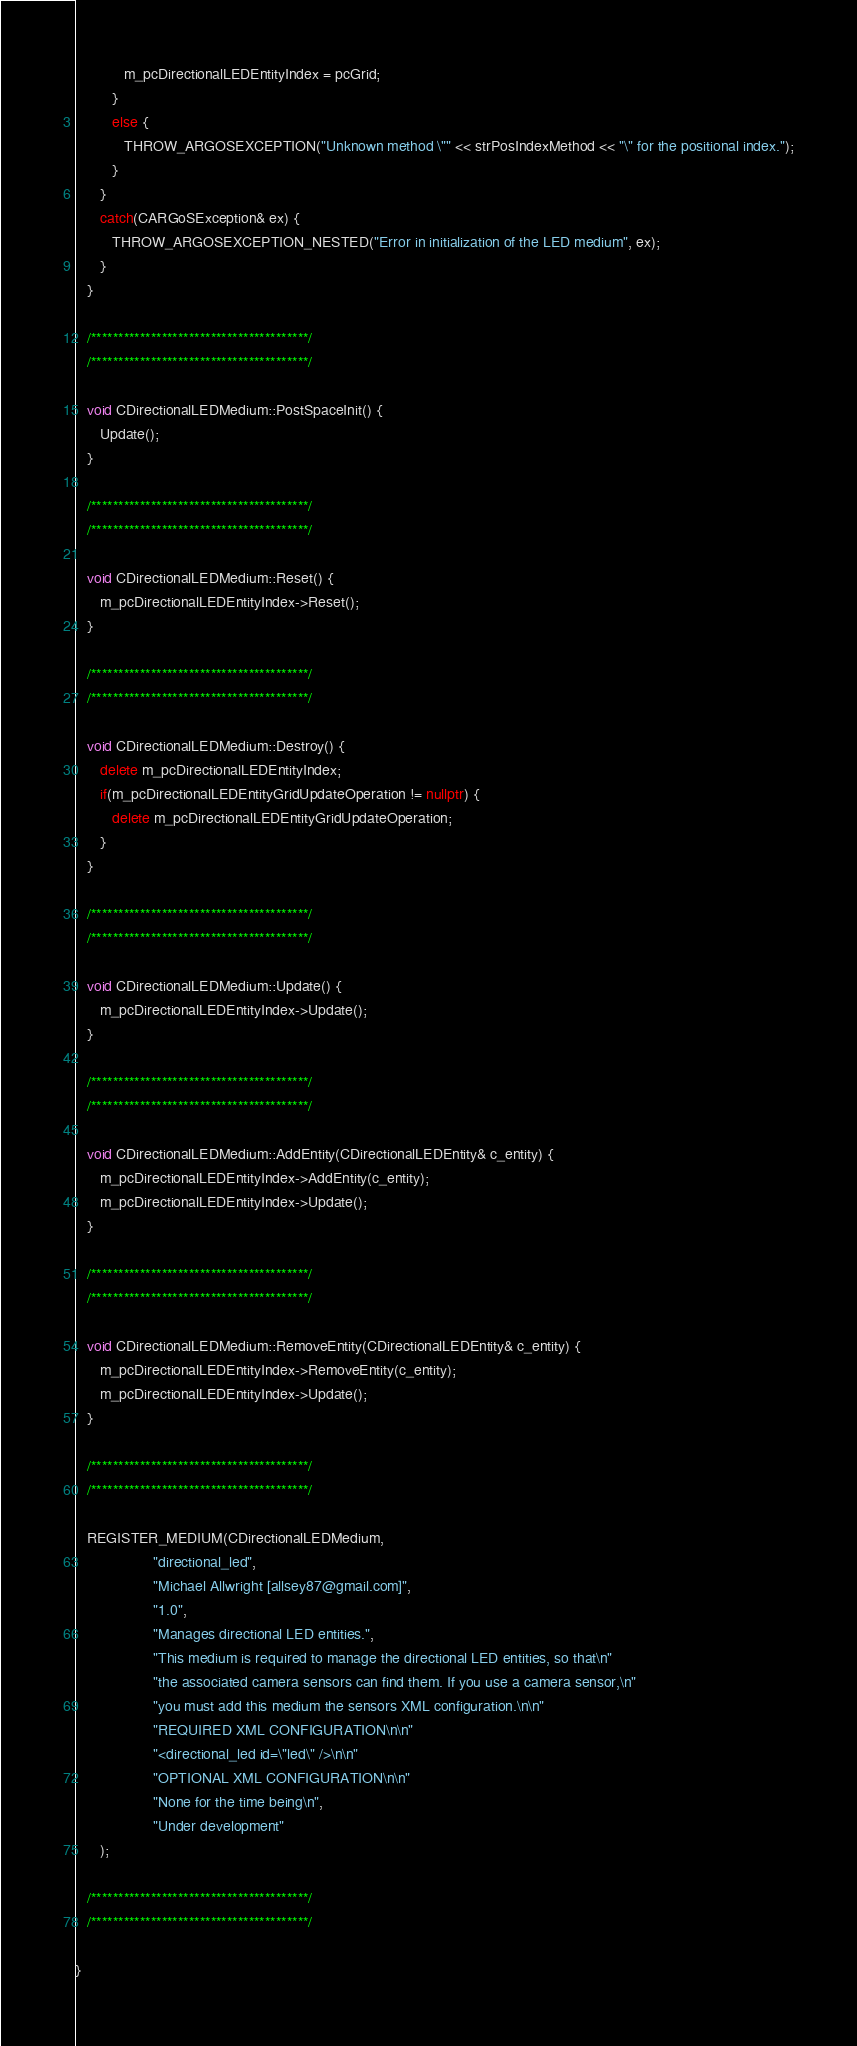Convert code to text. <code><loc_0><loc_0><loc_500><loc_500><_C++_>            m_pcDirectionalLEDEntityIndex = pcGrid;
         }
         else {
            THROW_ARGOSEXCEPTION("Unknown method \"" << strPosIndexMethod << "\" for the positional index.");
         }
      }
      catch(CARGoSException& ex) {
         THROW_ARGOSEXCEPTION_NESTED("Error in initialization of the LED medium", ex);
      }
   }

   /****************************************/
   /****************************************/

   void CDirectionalLEDMedium::PostSpaceInit() {
      Update();
   }

   /****************************************/
   /****************************************/

   void CDirectionalLEDMedium::Reset() {
      m_pcDirectionalLEDEntityIndex->Reset();
   }

   /****************************************/
   /****************************************/

   void CDirectionalLEDMedium::Destroy() {
      delete m_pcDirectionalLEDEntityIndex;
      if(m_pcDirectionalLEDEntityGridUpdateOperation != nullptr) {
         delete m_pcDirectionalLEDEntityGridUpdateOperation;
      }
   }

   /****************************************/
   /****************************************/

   void CDirectionalLEDMedium::Update() {
      m_pcDirectionalLEDEntityIndex->Update();
   }

   /****************************************/
   /****************************************/

   void CDirectionalLEDMedium::AddEntity(CDirectionalLEDEntity& c_entity) {
      m_pcDirectionalLEDEntityIndex->AddEntity(c_entity);
      m_pcDirectionalLEDEntityIndex->Update();
   }

   /****************************************/
   /****************************************/

   void CDirectionalLEDMedium::RemoveEntity(CDirectionalLEDEntity& c_entity) {
      m_pcDirectionalLEDEntityIndex->RemoveEntity(c_entity);
      m_pcDirectionalLEDEntityIndex->Update();
   }

   /****************************************/
   /****************************************/

   REGISTER_MEDIUM(CDirectionalLEDMedium,
                   "directional_led",
                   "Michael Allwright [allsey87@gmail.com]",
                   "1.0",
                   "Manages directional LED entities.",
                   "This medium is required to manage the directional LED entities, so that\n"
                   "the associated camera sensors can find them. If you use a camera sensor,\n"
                   "you must add this medium the sensors XML configuration.\n\n"
                   "REQUIRED XML CONFIGURATION\n\n"
                   "<directional_led id=\"led\" />\n\n"
                   "OPTIONAL XML CONFIGURATION\n\n"
                   "None for the time being\n",
                   "Under development"
      );

   /****************************************/
   /****************************************/

}
</code> 